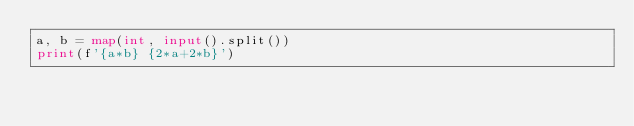Convert code to text. <code><loc_0><loc_0><loc_500><loc_500><_Python_>a, b = map(int, input().split())
print(f'{a*b} {2*a+2*b}')

</code> 